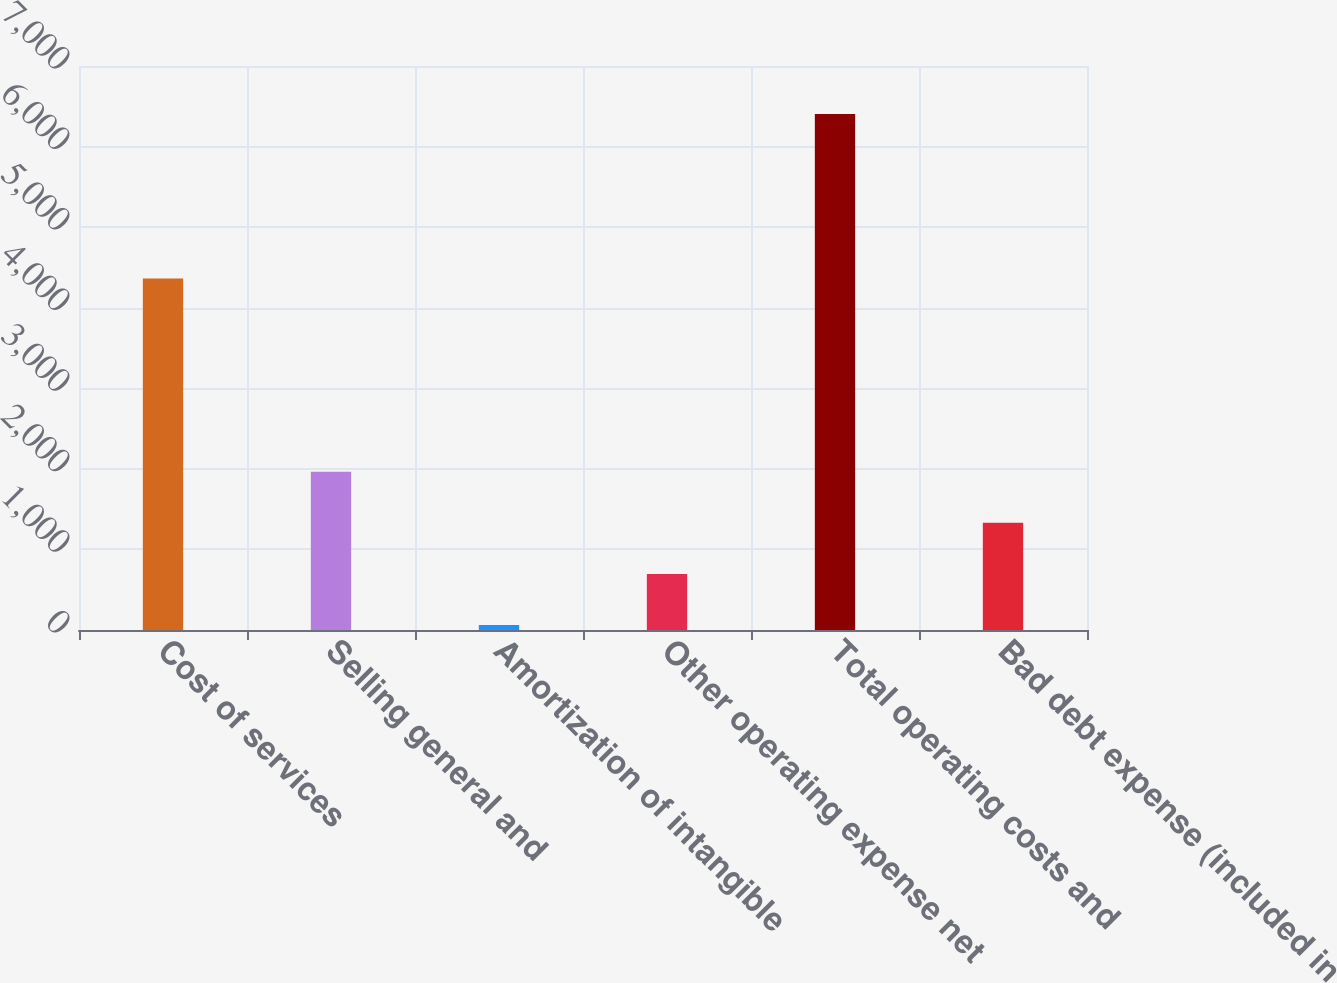<chart> <loc_0><loc_0><loc_500><loc_500><bar_chart><fcel>Cost of services<fcel>Selling general and<fcel>Amortization of intangible<fcel>Other operating expense net<fcel>Total operating costs and<fcel>Bad debt expense (included in<nl><fcel>4362.9<fcel>1964.43<fcel>61.2<fcel>695.61<fcel>6405.3<fcel>1330.02<nl></chart> 